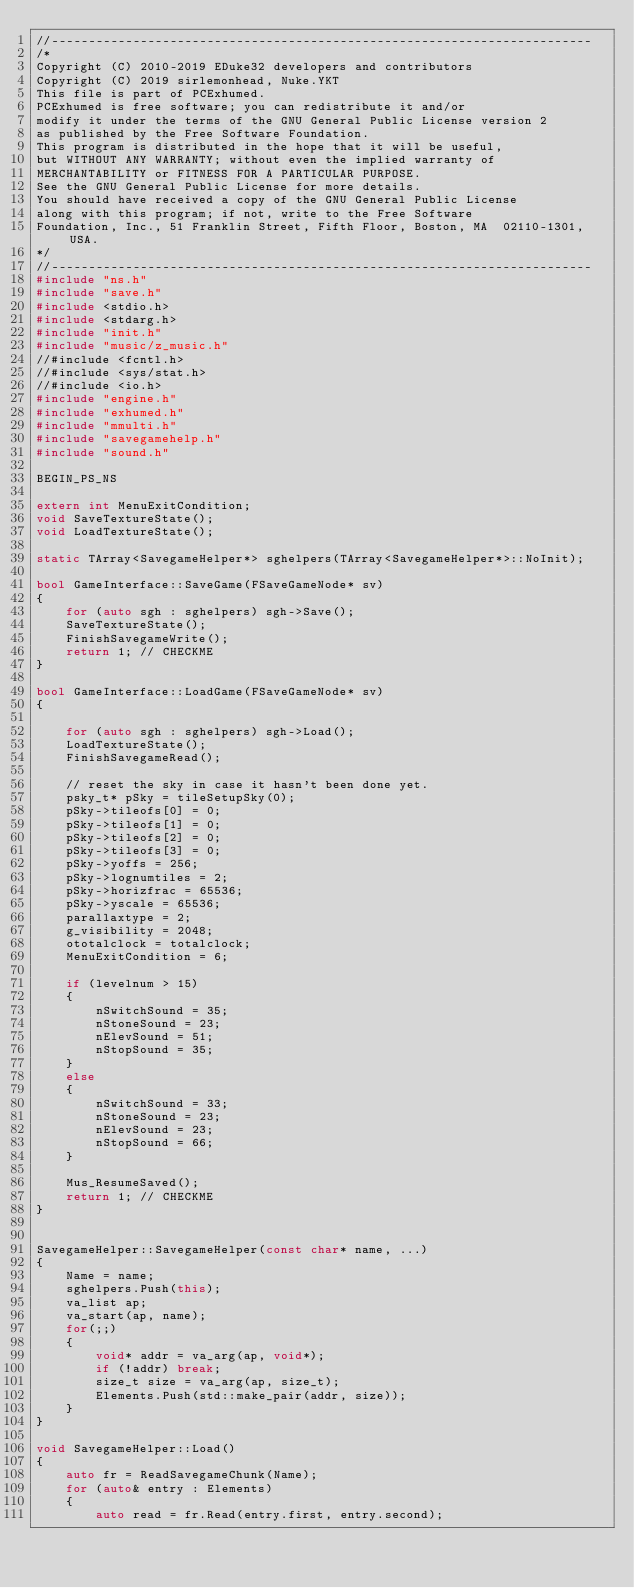Convert code to text. <code><loc_0><loc_0><loc_500><loc_500><_C++_>//-------------------------------------------------------------------------
/*
Copyright (C) 2010-2019 EDuke32 developers and contributors
Copyright (C) 2019 sirlemonhead, Nuke.YKT
This file is part of PCExhumed.
PCExhumed is free software; you can redistribute it and/or
modify it under the terms of the GNU General Public License version 2
as published by the Free Software Foundation.
This program is distributed in the hope that it will be useful,
but WITHOUT ANY WARRANTY; without even the implied warranty of
MERCHANTABILITY or FITNESS FOR A PARTICULAR PURPOSE.
See the GNU General Public License for more details.
You should have received a copy of the GNU General Public License
along with this program; if not, write to the Free Software
Foundation, Inc., 51 Franklin Street, Fifth Floor, Boston, MA  02110-1301, USA.
*/
//-------------------------------------------------------------------------
#include "ns.h"
#include "save.h"
#include <stdio.h>
#include <stdarg.h>
#include "init.h"
#include "music/z_music.h"
//#include <fcntl.h>
//#include <sys/stat.h>
//#include <io.h>
#include "engine.h"
#include "exhumed.h"
#include "mmulti.h"
#include "savegamehelp.h"
#include "sound.h"

BEGIN_PS_NS

extern int MenuExitCondition;
void SaveTextureState();
void LoadTextureState();

static TArray<SavegameHelper*> sghelpers(TArray<SavegameHelper*>::NoInit);

bool GameInterface::SaveGame(FSaveGameNode* sv)
{
    for (auto sgh : sghelpers) sgh->Save();
    SaveTextureState();
    FinishSavegameWrite();
    return 1; // CHECKME
}

bool GameInterface::LoadGame(FSaveGameNode* sv)
{

    for (auto sgh : sghelpers) sgh->Load();
    LoadTextureState();
    FinishSavegameRead();

    // reset the sky in case it hasn't been done yet.
    psky_t* pSky = tileSetupSky(0);
    pSky->tileofs[0] = 0;
    pSky->tileofs[1] = 0;
    pSky->tileofs[2] = 0;
    pSky->tileofs[3] = 0;
    pSky->yoffs = 256;
    pSky->lognumtiles = 2;
    pSky->horizfrac = 65536;
    pSky->yscale = 65536;
    parallaxtype = 2;
    g_visibility = 2048;
    ototalclock = totalclock;
    MenuExitCondition = 6;

    if (levelnum > 15)
    {
        nSwitchSound = 35;
        nStoneSound = 23;
        nElevSound = 51;
        nStopSound = 35;
    }
    else
    {
        nSwitchSound = 33;
        nStoneSound = 23;
        nElevSound = 23;
        nStopSound = 66;
    }

    Mus_ResumeSaved();
    return 1; // CHECKME
}


SavegameHelper::SavegameHelper(const char* name, ...)
{
    Name = name;
    sghelpers.Push(this);
    va_list ap;
    va_start(ap, name);
    for(;;)
    {
        void* addr = va_arg(ap, void*);
        if (!addr) break;
        size_t size = va_arg(ap, size_t);
        Elements.Push(std::make_pair(addr, size));
    }
}

void SavegameHelper::Load()
{
    auto fr = ReadSavegameChunk(Name);
    for (auto& entry : Elements)
    {
        auto read = fr.Read(entry.first, entry.second);</code> 